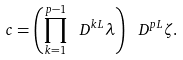<formula> <loc_0><loc_0><loc_500><loc_500>c = \left ( \prod _ { k = 1 } ^ { p - 1 } \ D ^ { k L } \lambda \right ) \ D ^ { p L } \zeta .</formula> 